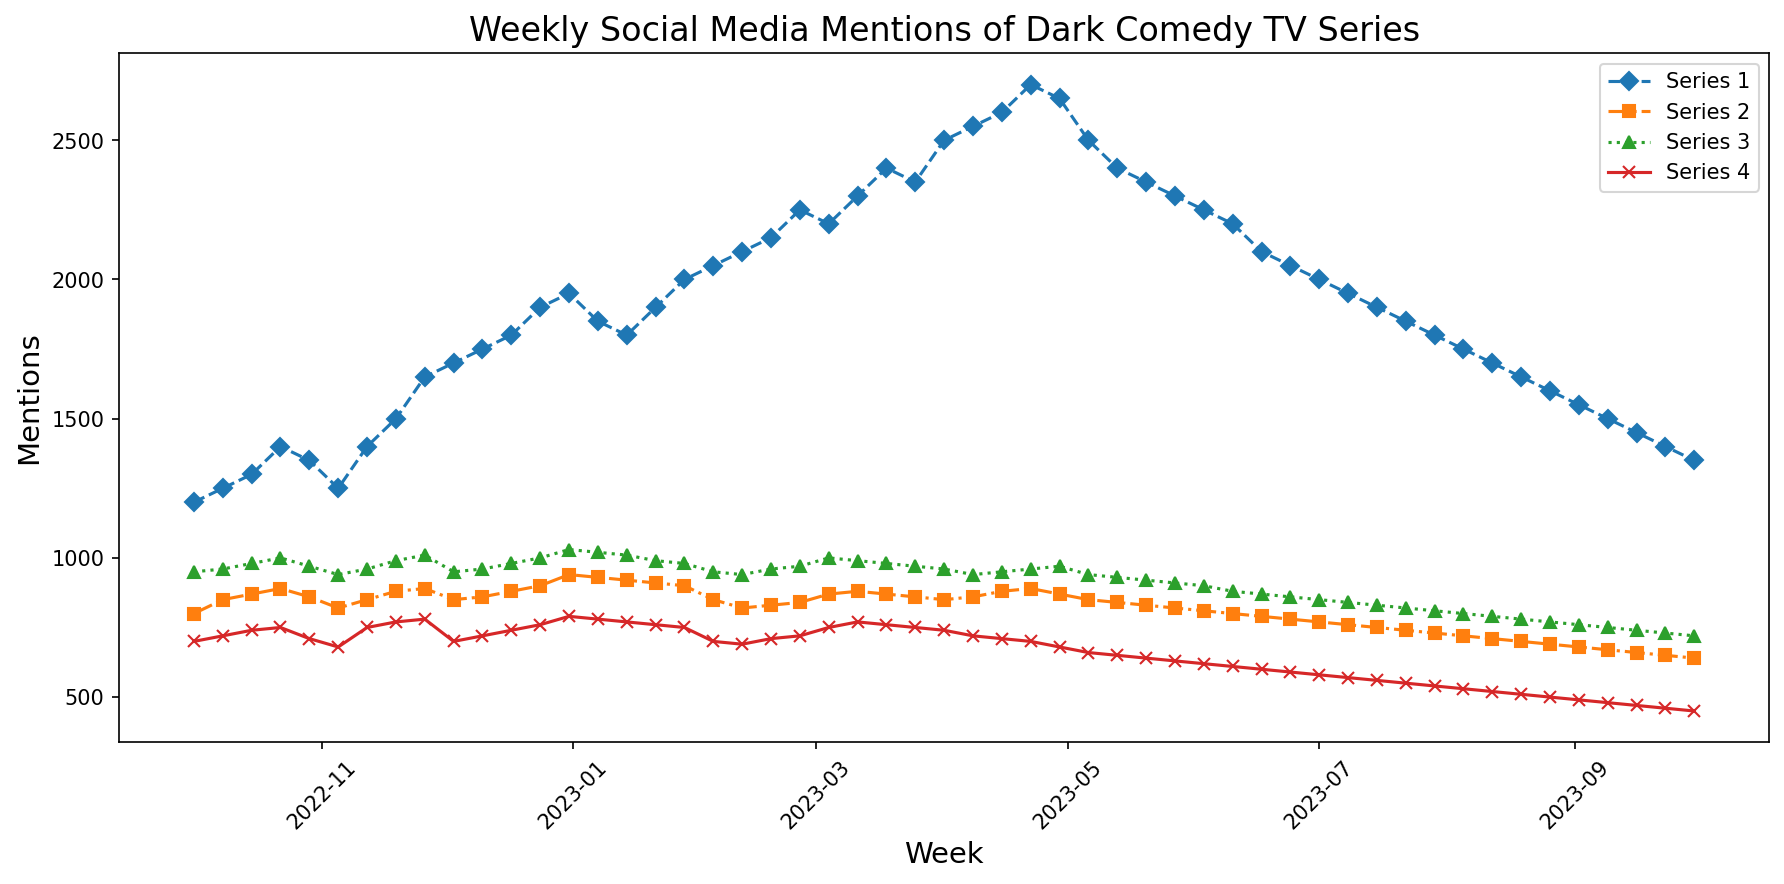What is the trend in mentions for Series 1 over the past year? To determine the trend for Series 1, look at the line corresponding to Series 1 on the plot. Notice that the line shows a general increase in mentions over time, reaching a peak around April and then declining slightly after July.
Answer: Increasing trend with a peak in April Which series had the highest number of mentions in the last week of December? Examine the lines and their values at the end of December. Series 1 has the highest number of mentions with approximately 1950 mentions in the last week of December.
Answer: Series 1 By how much did the mentions of Series 2 decrease from the beginning to the end of the plot? At the beginning (first week of October 2022), Series 2 had 800 mentions. At the end (last week of September 2023), Series 2 had 640 mentions. The decrease is 800 - 640 = 160.
Answer: 160 Which series exhibited the least overall variation in mentions throughout the year? To find the series with the least variation, compare the range (difference between the highest and lowest mentions) for each series. Series 4 fluctuates between 700 and 450, which is a range of 250, the least compared to others.
Answer: Series 4 What can be said about the mentions of Series 3 around May compared to March? In March, Series 3 had mentions ranging around 970-1000. In May, the mentions declined to around 940. Therefore, there is a noticeable decrease.
Answer: Decreased How many weeks did Series 1 have mentions greater than 2000? Count the number of points where Series 1 mentions are above 2000. It was greater than 2000 for 6 weeks (from Feb to April).
Answer: 6 weeks During which months did Series 4 have its lowest mentions? Identify the lowest points in the plot for Series 4, which occur around July to September, showing the lowest mentions during these months.
Answer: July to September Between which two series is the difference in mentions greatest during February? Compare the lines for each series in February. The greatest difference in mentions in February is between Series 1 (around 2150) and Series 4 (around 690), which is 2150 - 690 = 1460.
Answer: Series 1 and Series 4 Which series had a peak in mentions in the middle of November? Observe the peaks for each series and locate the highest point in the middle of November. Series 3 peaks at around 1010 mentions.
Answer: Series 3 How do the mentions of Series 1 in October compare to those in April? Compare the values of Series 1 in October (around 1300-1400) and April (around 2600-2700), showing that the mentions in April are roughly double those in October.
Answer: Roughly doubled 